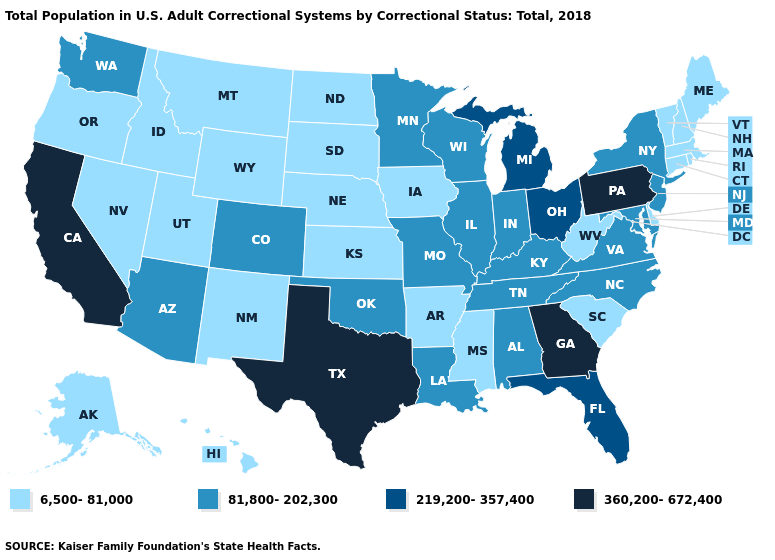Name the states that have a value in the range 219,200-357,400?
Give a very brief answer. Florida, Michigan, Ohio. What is the lowest value in the Northeast?
Answer briefly. 6,500-81,000. Name the states that have a value in the range 6,500-81,000?
Concise answer only. Alaska, Arkansas, Connecticut, Delaware, Hawaii, Idaho, Iowa, Kansas, Maine, Massachusetts, Mississippi, Montana, Nebraska, Nevada, New Hampshire, New Mexico, North Dakota, Oregon, Rhode Island, South Carolina, South Dakota, Utah, Vermont, West Virginia, Wyoming. What is the highest value in the South ?
Concise answer only. 360,200-672,400. Does Texas have a lower value than South Carolina?
Be succinct. No. Does Tennessee have a higher value than West Virginia?
Keep it brief. Yes. Name the states that have a value in the range 360,200-672,400?
Keep it brief. California, Georgia, Pennsylvania, Texas. What is the value of Maine?
Answer briefly. 6,500-81,000. Name the states that have a value in the range 219,200-357,400?
Concise answer only. Florida, Michigan, Ohio. Among the states that border Alabama , does Florida have the highest value?
Give a very brief answer. No. What is the highest value in the Northeast ?
Concise answer only. 360,200-672,400. Name the states that have a value in the range 219,200-357,400?
Short answer required. Florida, Michigan, Ohio. Among the states that border Indiana , which have the highest value?
Answer briefly. Michigan, Ohio. Name the states that have a value in the range 360,200-672,400?
Be succinct. California, Georgia, Pennsylvania, Texas. 